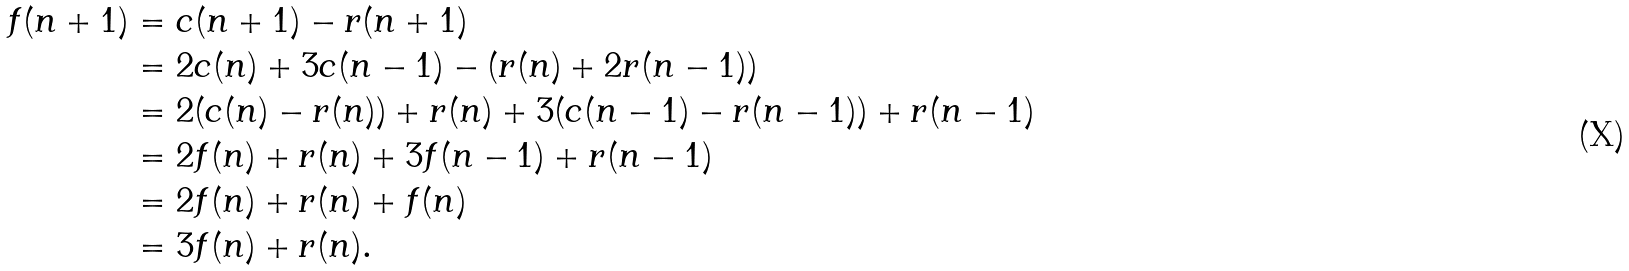<formula> <loc_0><loc_0><loc_500><loc_500>f ( n + 1 ) & = c ( n + 1 ) - r ( n + 1 ) \\ & = 2 c ( n ) + 3 c ( n - 1 ) - ( r ( n ) + 2 r ( n - 1 ) ) \\ & = 2 ( c ( n ) - r ( n ) ) + r ( n ) + 3 ( c ( n - 1 ) - r ( n - 1 ) ) + r ( n - 1 ) \\ & = 2 f ( n ) + r ( n ) + 3 f ( n - 1 ) + r ( n - 1 ) \\ & = 2 f ( n ) + r ( n ) + f ( n ) \\ & = 3 f ( n ) + r ( n ) .</formula> 